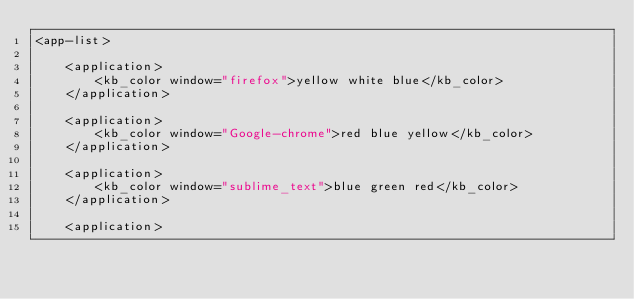<code> <loc_0><loc_0><loc_500><loc_500><_XML_><app-list>

    <application>
        <kb_color window="firefox">yellow white blue</kb_color>
    </application>

    <application>
        <kb_color window="Google-chrome">red blue yellow</kb_color>
    </application>

    <application>
        <kb_color window="sublime_text">blue green red</kb_color>
    </application>

    <application></code> 